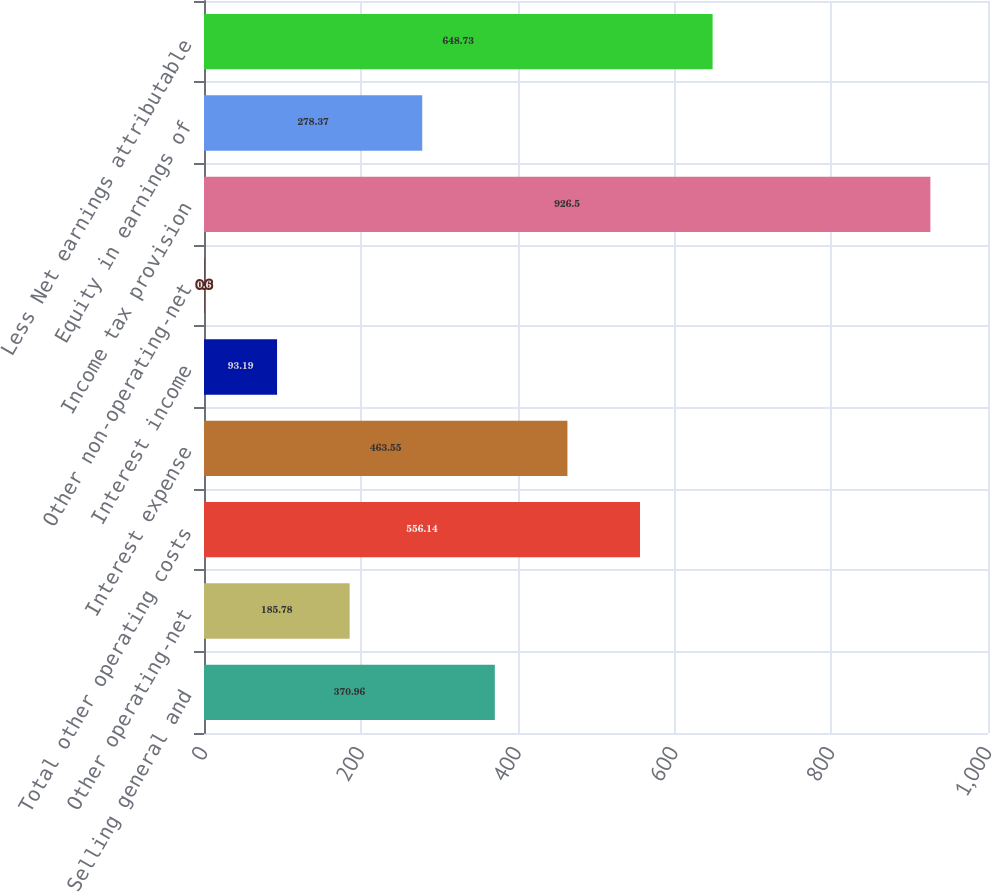<chart> <loc_0><loc_0><loc_500><loc_500><bar_chart><fcel>Selling general and<fcel>Other operating-net<fcel>Total other operating costs<fcel>Interest expense<fcel>Interest income<fcel>Other non-operating-net<fcel>Income tax provision<fcel>Equity in earnings of<fcel>Less Net earnings attributable<nl><fcel>370.96<fcel>185.78<fcel>556.14<fcel>463.55<fcel>93.19<fcel>0.6<fcel>926.5<fcel>278.37<fcel>648.73<nl></chart> 